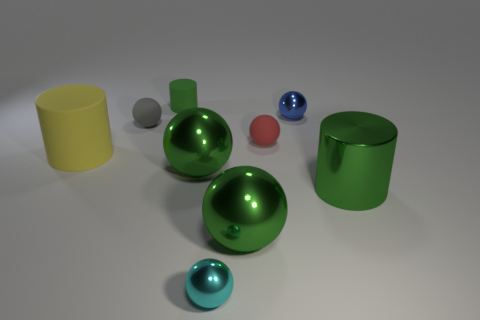Describe the lighting in this scene. Where do you think the light source is? The lighting in this scene is diffused and soft, creating gentle shadows and highlights on the objects. There are no harsh shadows, indicating the light source is not directly above but rather might be off to the side or above at a certain angle. It gives the impression of a studio setting with a possibly overhead softbox or a similarly diffused light source to illuminate the scene evenly. 